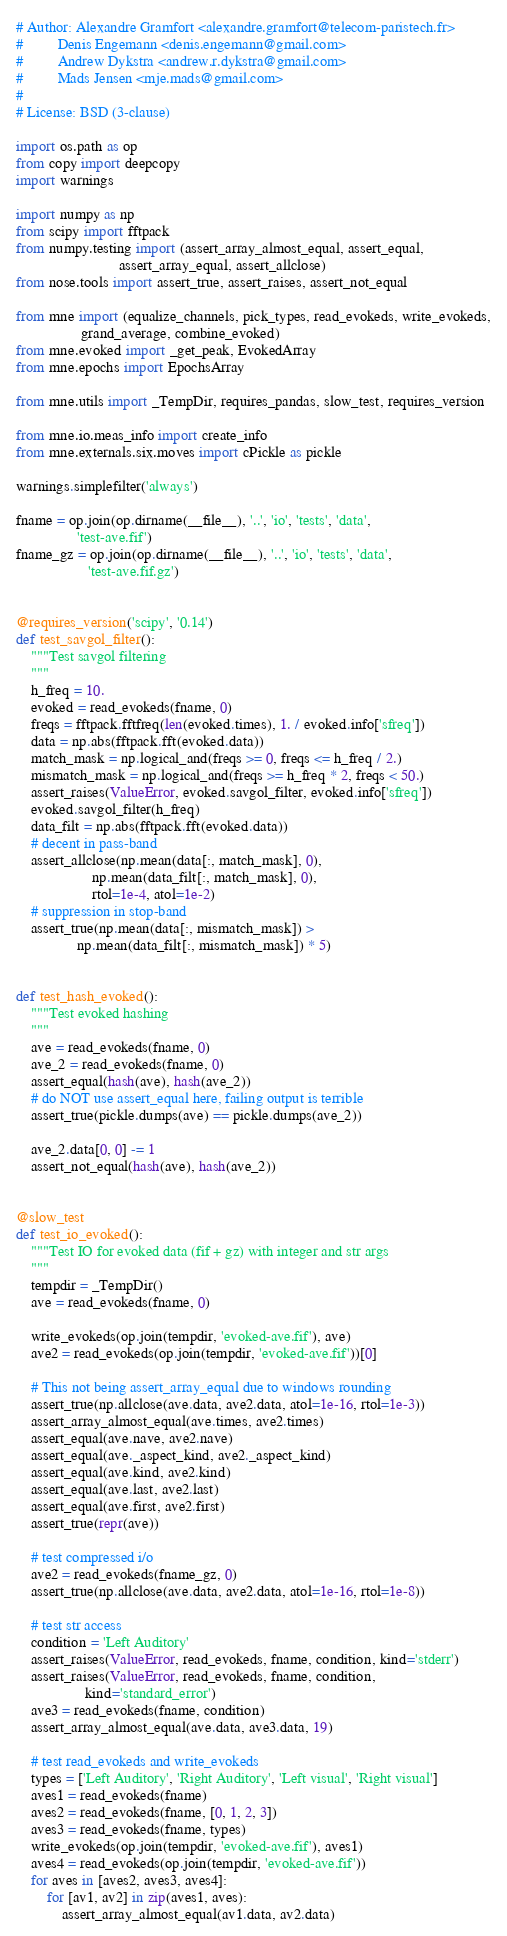Convert code to text. <code><loc_0><loc_0><loc_500><loc_500><_Python_># Author: Alexandre Gramfort <alexandre.gramfort@telecom-paristech.fr>
#         Denis Engemann <denis.engemann@gmail.com>
#         Andrew Dykstra <andrew.r.dykstra@gmail.com>
#         Mads Jensen <mje.mads@gmail.com>
#
# License: BSD (3-clause)

import os.path as op
from copy import deepcopy
import warnings

import numpy as np
from scipy import fftpack
from numpy.testing import (assert_array_almost_equal, assert_equal,
                           assert_array_equal, assert_allclose)
from nose.tools import assert_true, assert_raises, assert_not_equal

from mne import (equalize_channels, pick_types, read_evokeds, write_evokeds,
                 grand_average, combine_evoked)
from mne.evoked import _get_peak, EvokedArray
from mne.epochs import EpochsArray

from mne.utils import _TempDir, requires_pandas, slow_test, requires_version

from mne.io.meas_info import create_info
from mne.externals.six.moves import cPickle as pickle

warnings.simplefilter('always')

fname = op.join(op.dirname(__file__), '..', 'io', 'tests', 'data',
                'test-ave.fif')
fname_gz = op.join(op.dirname(__file__), '..', 'io', 'tests', 'data',
                   'test-ave.fif.gz')


@requires_version('scipy', '0.14')
def test_savgol_filter():
    """Test savgol filtering
    """
    h_freq = 10.
    evoked = read_evokeds(fname, 0)
    freqs = fftpack.fftfreq(len(evoked.times), 1. / evoked.info['sfreq'])
    data = np.abs(fftpack.fft(evoked.data))
    match_mask = np.logical_and(freqs >= 0, freqs <= h_freq / 2.)
    mismatch_mask = np.logical_and(freqs >= h_freq * 2, freqs < 50.)
    assert_raises(ValueError, evoked.savgol_filter, evoked.info['sfreq'])
    evoked.savgol_filter(h_freq)
    data_filt = np.abs(fftpack.fft(evoked.data))
    # decent in pass-band
    assert_allclose(np.mean(data[:, match_mask], 0),
                    np.mean(data_filt[:, match_mask], 0),
                    rtol=1e-4, atol=1e-2)
    # suppression in stop-band
    assert_true(np.mean(data[:, mismatch_mask]) >
                np.mean(data_filt[:, mismatch_mask]) * 5)


def test_hash_evoked():
    """Test evoked hashing
    """
    ave = read_evokeds(fname, 0)
    ave_2 = read_evokeds(fname, 0)
    assert_equal(hash(ave), hash(ave_2))
    # do NOT use assert_equal here, failing output is terrible
    assert_true(pickle.dumps(ave) == pickle.dumps(ave_2))

    ave_2.data[0, 0] -= 1
    assert_not_equal(hash(ave), hash(ave_2))


@slow_test
def test_io_evoked():
    """Test IO for evoked data (fif + gz) with integer and str args
    """
    tempdir = _TempDir()
    ave = read_evokeds(fname, 0)

    write_evokeds(op.join(tempdir, 'evoked-ave.fif'), ave)
    ave2 = read_evokeds(op.join(tempdir, 'evoked-ave.fif'))[0]

    # This not being assert_array_equal due to windows rounding
    assert_true(np.allclose(ave.data, ave2.data, atol=1e-16, rtol=1e-3))
    assert_array_almost_equal(ave.times, ave2.times)
    assert_equal(ave.nave, ave2.nave)
    assert_equal(ave._aspect_kind, ave2._aspect_kind)
    assert_equal(ave.kind, ave2.kind)
    assert_equal(ave.last, ave2.last)
    assert_equal(ave.first, ave2.first)
    assert_true(repr(ave))

    # test compressed i/o
    ave2 = read_evokeds(fname_gz, 0)
    assert_true(np.allclose(ave.data, ave2.data, atol=1e-16, rtol=1e-8))

    # test str access
    condition = 'Left Auditory'
    assert_raises(ValueError, read_evokeds, fname, condition, kind='stderr')
    assert_raises(ValueError, read_evokeds, fname, condition,
                  kind='standard_error')
    ave3 = read_evokeds(fname, condition)
    assert_array_almost_equal(ave.data, ave3.data, 19)

    # test read_evokeds and write_evokeds
    types = ['Left Auditory', 'Right Auditory', 'Left visual', 'Right visual']
    aves1 = read_evokeds(fname)
    aves2 = read_evokeds(fname, [0, 1, 2, 3])
    aves3 = read_evokeds(fname, types)
    write_evokeds(op.join(tempdir, 'evoked-ave.fif'), aves1)
    aves4 = read_evokeds(op.join(tempdir, 'evoked-ave.fif'))
    for aves in [aves2, aves3, aves4]:
        for [av1, av2] in zip(aves1, aves):
            assert_array_almost_equal(av1.data, av2.data)</code> 